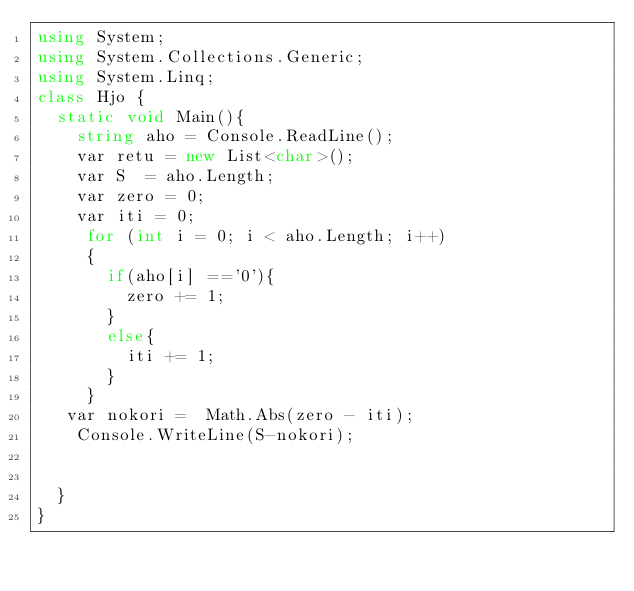<code> <loc_0><loc_0><loc_500><loc_500><_C#_>using System;
using System.Collections.Generic;
using System.Linq;
class Hjo {
  static void Main(){
    string aho = Console.ReadLine();
    var retu = new List<char>();
    var S  = aho.Length;
    var zero = 0;
    var iti = 0;
     for (int i = 0; i < aho.Length; i++)
     {
       if(aho[i] =='0'){
         zero += 1;
       }
       else{
         iti += 1;
       }
     }
   var nokori =  Math.Abs(zero - iti);
    Console.WriteLine(S-nokori);
  
       
  }
}</code> 